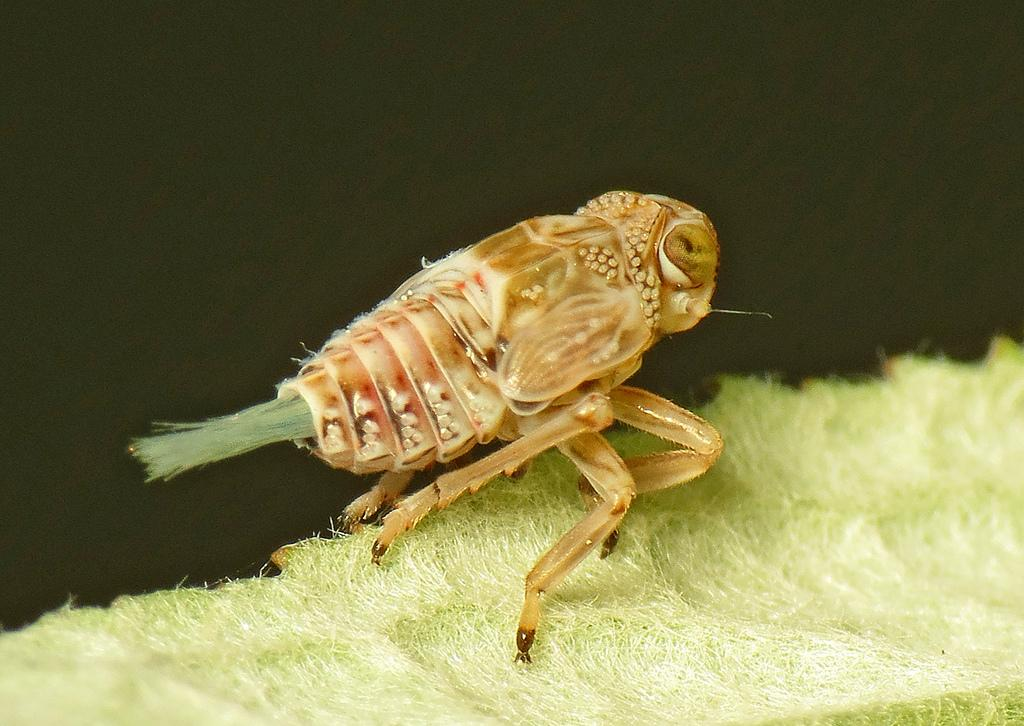What type of creature can be seen in the image? There is an insect in the image. What is the color of the insect? The insect is brown in color. Where is the insect located in the image? The insect is on an object. What is the color of the object the insect is on? The object is green in color. What attempt did the son make to reduce the noise in the image? There is no son or noise present in the image; it only features an insect on a green object. 